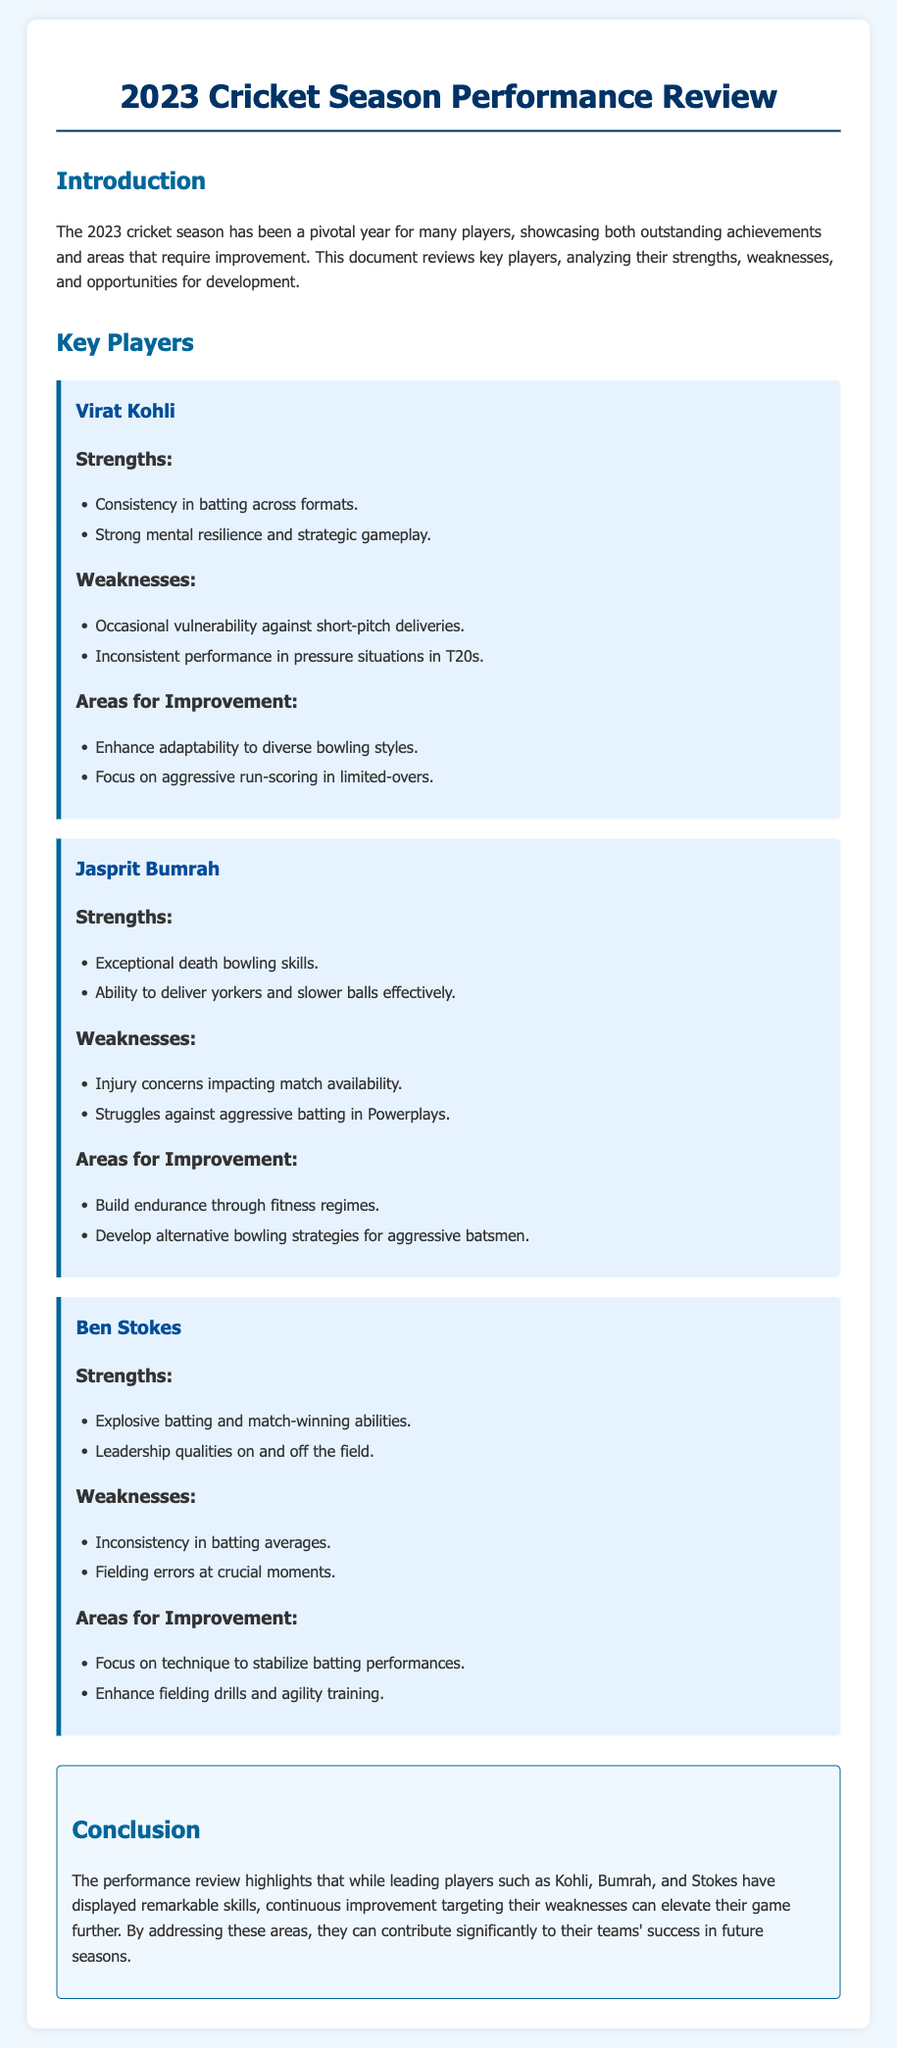What is the title of the document? The title of the document is specified in the HTML <title> tag, which is "2023 Cricket Season Performance Review."
Answer: 2023 Cricket Season Performance Review Which player is noted for "exceptional death bowling skills"? This information is found in the strengths section of Jasprit Bumrah's player card.
Answer: Jasprit Bumrah What is a noted weakness for Virat Kohli? The weakness is indicated in the weaknesses section of his player card, specifically mentioning his occasional vulnerability against short-pitch deliveries.
Answer: Occasional vulnerability against short-pitch deliveries How many key players are reviewed in the document? The document lists three key players with performance reviews.
Answer: Three What area for improvement is highlighted for Ben Stokes? The area for improvement is mentioned in his player card under "Areas for Improvement," focusing on stabilizing batting performances through technique.
Answer: Focus on technique to stabilize batting performances Which player is recognized for their leadership qualities? This detail can be found in the strengths section of Ben Stokes's player card.
Answer: Ben Stokes What color is used for the document's background? The background color is specified in the CSS styles as light blue, represented by the hexadecimal code #f0f8ff.
Answer: #f0f8ff What month does the 2023 cricket season conclude? Although the exact month is not mentioned in the document, it refers to the entire 2023 season in its title and introduction.
Answer: Not specified What is a common theme in the conclusion of the document? The conclusion emphasizes the need for players to address their weaknesses for improvement moving forward.
Answer: Continuous improvement targeting weaknesses 